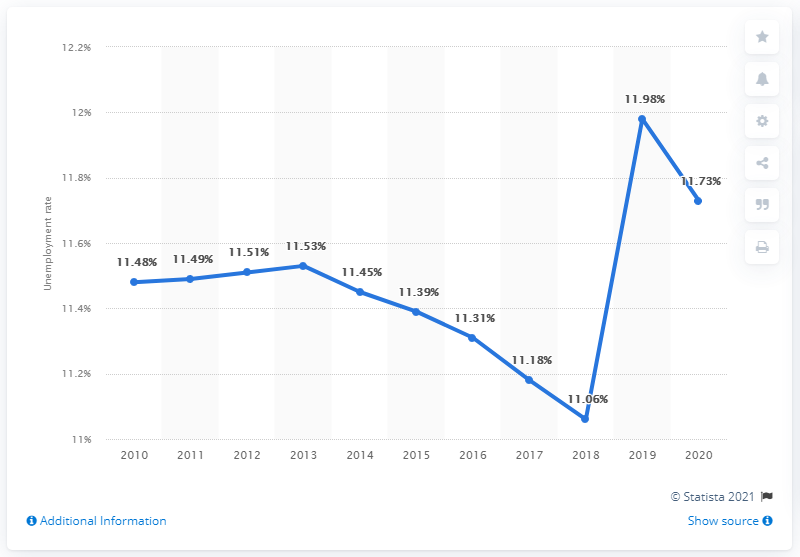Draw attention to some important aspects in this diagram. In 2020, the unemployment rate in Afghanistan was 11.06%. 